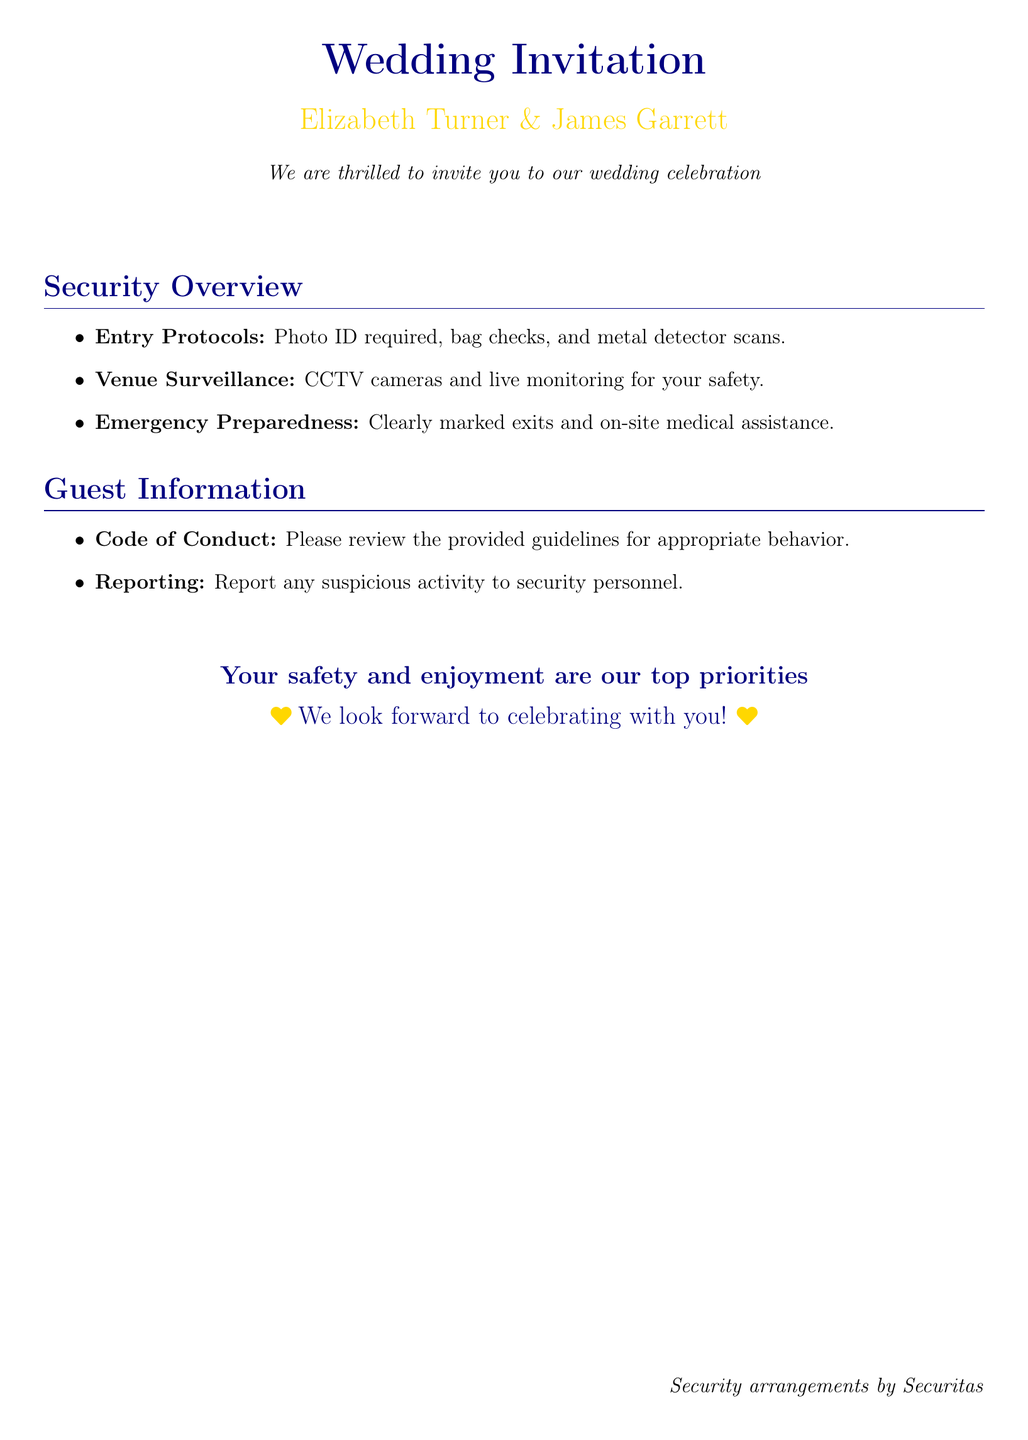what is required for entry? The document states that a Photo ID is required for entry along with additional checks.
Answer: Photo ID what security measures are in place for the venue? The document mentions CCTV cameras and live monitoring as security measures at the venue.
Answer: CCTV cameras and live monitoring what type of assistance will be available on-site? The document indicates that there will be on-site medical assistance.
Answer: On-site medical assistance who is responsible for the security arrangements? According to the document, Securitas is responsible for the security arrangements.
Answer: Securitas what should guests do if they see suspicious activity? The document advises guests to report any suspicious activity to security personnel.
Answer: Report to security personnel what color is the text used for the names of the couple? The document specifies that the names of the couple are presented in gold color.
Answer: Gold how is the code of conduct provided to guests? The document does not specify the medium but mentions it in the guest information section.
Answer: Provided guidelines what is the purpose of the venue surveillance? The document states that CCTV cameras and live monitoring are for safety.
Answer: For safety what is stated as the top priority for the wedding? The document explicitly states that safety and enjoyment are top priorities.
Answer: Safety and enjoyment 